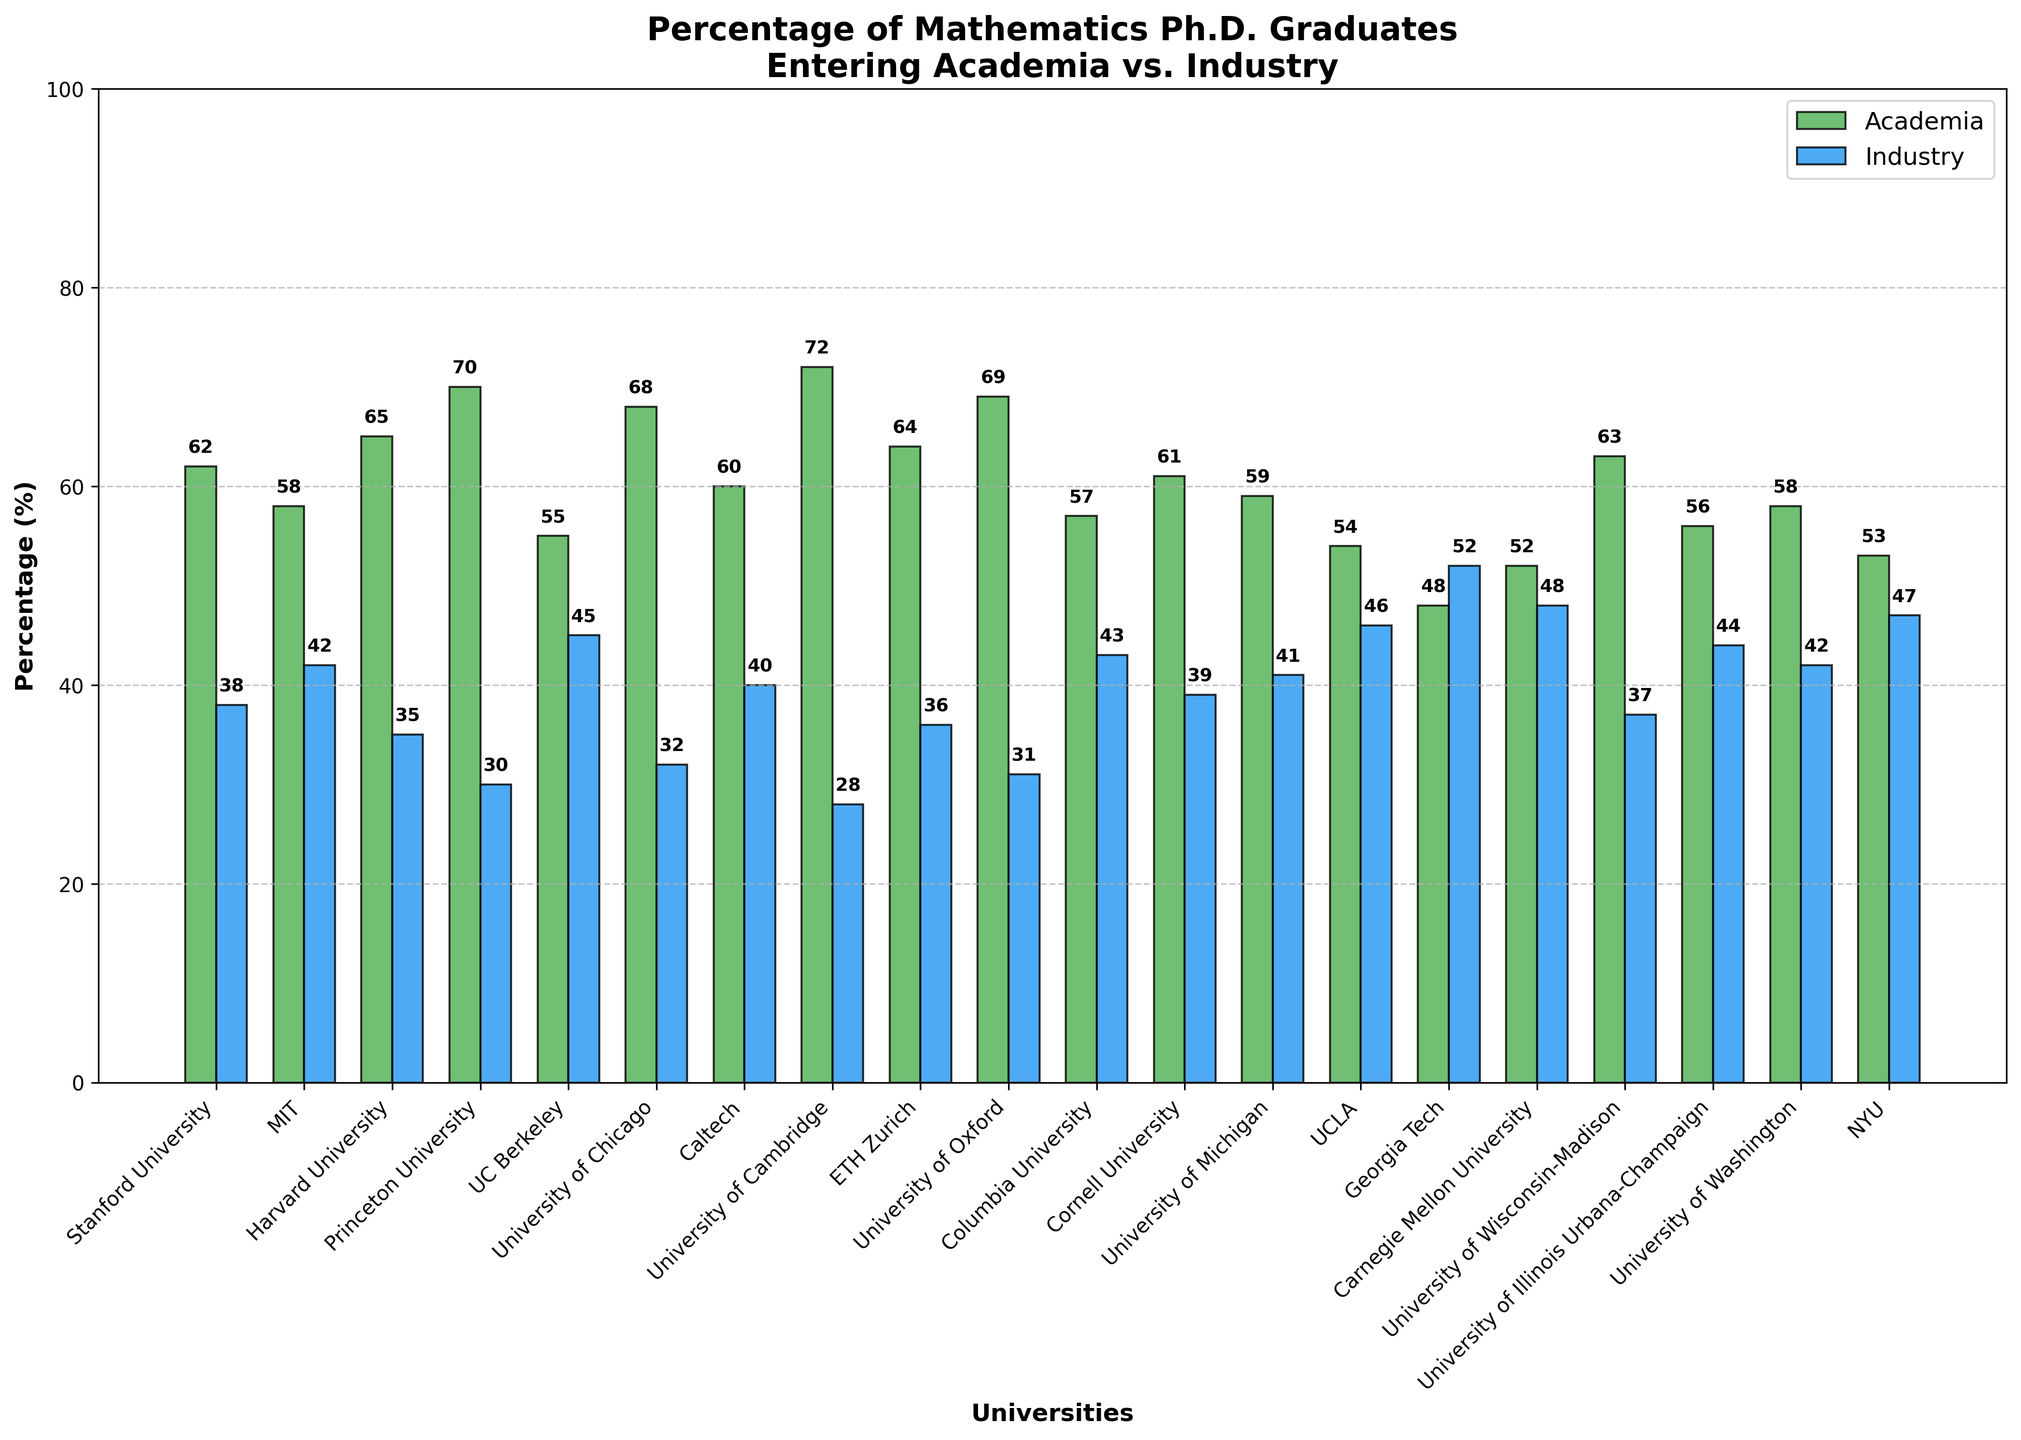What university has the highest percentage of Ph.D. graduates entering academia? Look for the tallest green bar in the chart which represents the percentage entering academia. The tallest green bar corresponds to the University of Cambridge.
Answer: University of Cambridge What is the difference in percentage of Ph.D. graduates entering industry between UC Berkeley and MIT? Identify the blue bars for UC Berkeley and MIT. UC Berkeley has 45% and MIT has 42%. Subtract MIT’s percentage from UC Berkeley’s. \(45 - 42 = 3\)
Answer: 3% Which universities show that more than 60% of their Ph.D. graduates enter academia? Identify the green bars higher than 60%: Stanford, Harvard, Princeton, University of Chicago, University of Cambridge, ETH Zurich, University of Oxford, and University of Wisconsin-Madison.
Answer: Stanford, Harvard, Princeton, University of Chicago, University of Cambridge, ETH Zurich, University of Oxford, University of Wisconsin-Madison Name the two universities where the difference between the percentage of graduates entering academia and industry is exactly 20%. Compare the height difference between green and blue bars for all universities. The universities that meet this condition are Stanford and Caltech. Both show a 62% (academia) - 38% (industry) = 24% difference.
Answer: Stanford University, Caltech What is the average percentage of Ph.D. graduates entering industry for the universities listed? Add the industry percentages and divide by the number of universities: \(\frac{38 + 42 + 35 + 30 + 45 + 32 + 40 + 28 + 36 + 31 + 43 + 39 + 41 + 46 + 52 + 48 + 37 + 44 + 42 + 47}{20} = 39\).
Answer: 39% Compare the percentages of graduates entering academia in Cornell University and University of Illinois Urbana-Champaign. Identify and compare the green bars for Cornell University (61%) and University of Illinois Urbana-Champaign (56%). Cornell University has a higher percentage.
Answer: Cornell University Which university has the smallest difference between the percentage of graduates entering academia and industry? Look for bars closest in height. Georgia Tech has the smallest gap between its academia (48%) and industry (52%) percentages.
Answer: Georgia Tech How much more (in percentage points) do Harvard's Ph.D. graduates enter academia compared to UCLA? Identify Harvard’s academia percentage (65%) and UCLA’s (54%). Subtract UCLA’s from Harvard’s: \(65 - 54 = 11\).
Answer: 11% What is the visual trend observed in the difference between academia and industry percentages among top universities? By scanning the relative bar heights, most universities tend to have a higher percentage of graduates entering academia except for Georgia Tech and a few others where the opposite is true.
Answer: Academia generally higher If you sum the percentages of graduates entering academia from Princeton, Harvard, and Stanford, what is the total percentage? Add the percentages from each university: \(70 + 65 + 62 = 197\).
Answer: 197% 